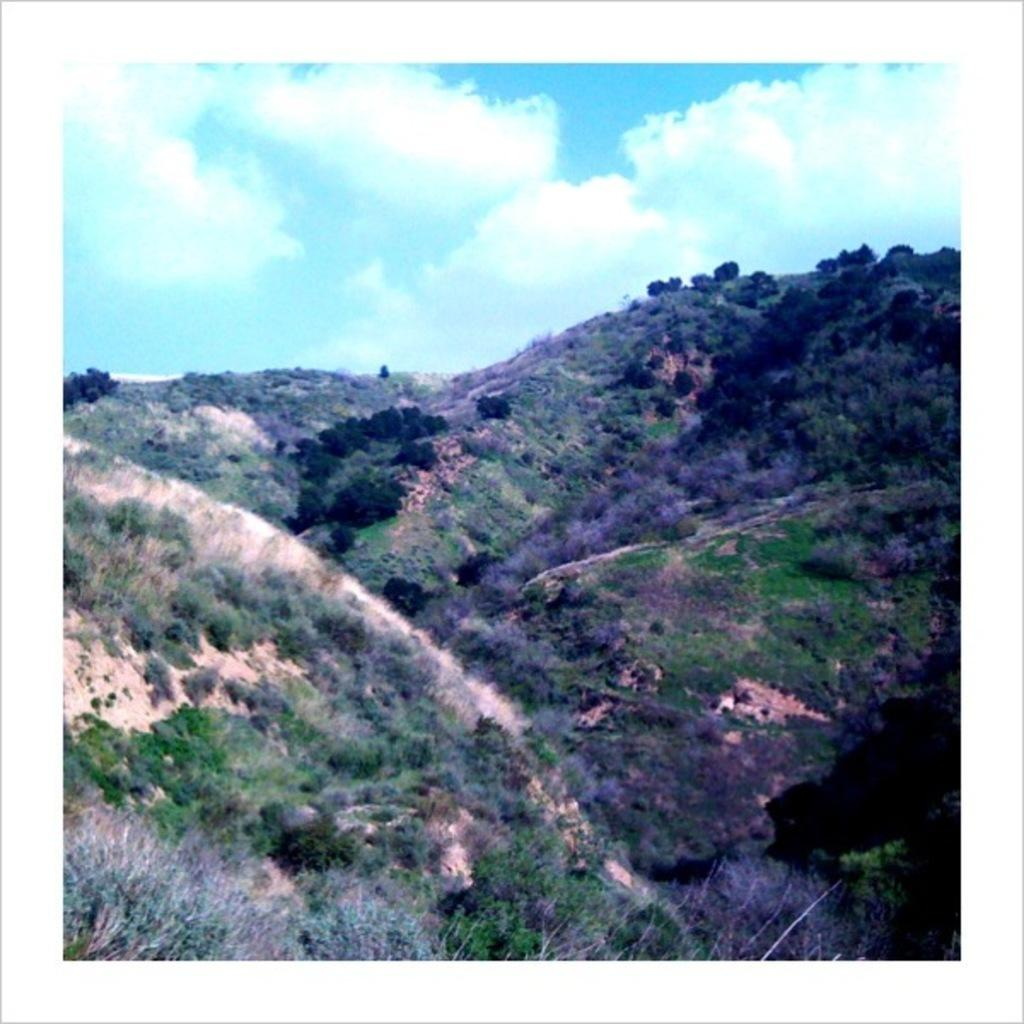What is the main subject of the image? The main subject of the image is a photo. What type of natural scenery is visible in the image? There are plants and hills visible in the image. What is visible in the background of the image? The sky is visible in the image. Where is the alley located in the image? There is no alley present in the image. What type of throne can be seen in the image? There is no throne present in the image. 